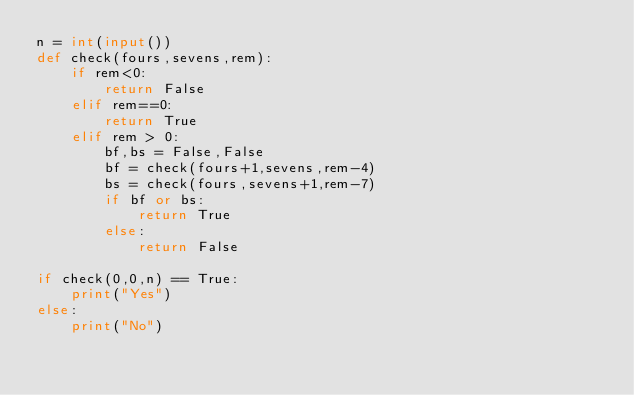Convert code to text. <code><loc_0><loc_0><loc_500><loc_500><_Python_>n = int(input())
def check(fours,sevens,rem):
    if rem<0:
        return False
    elif rem==0:
        return True
    elif rem > 0:
        bf,bs = False,False
        bf = check(fours+1,sevens,rem-4)
        bs = check(fours,sevens+1,rem-7)
        if bf or bs:
            return True
        else:
            return False
        
if check(0,0,n) == True:
    print("Yes")
else:
    print("No")</code> 